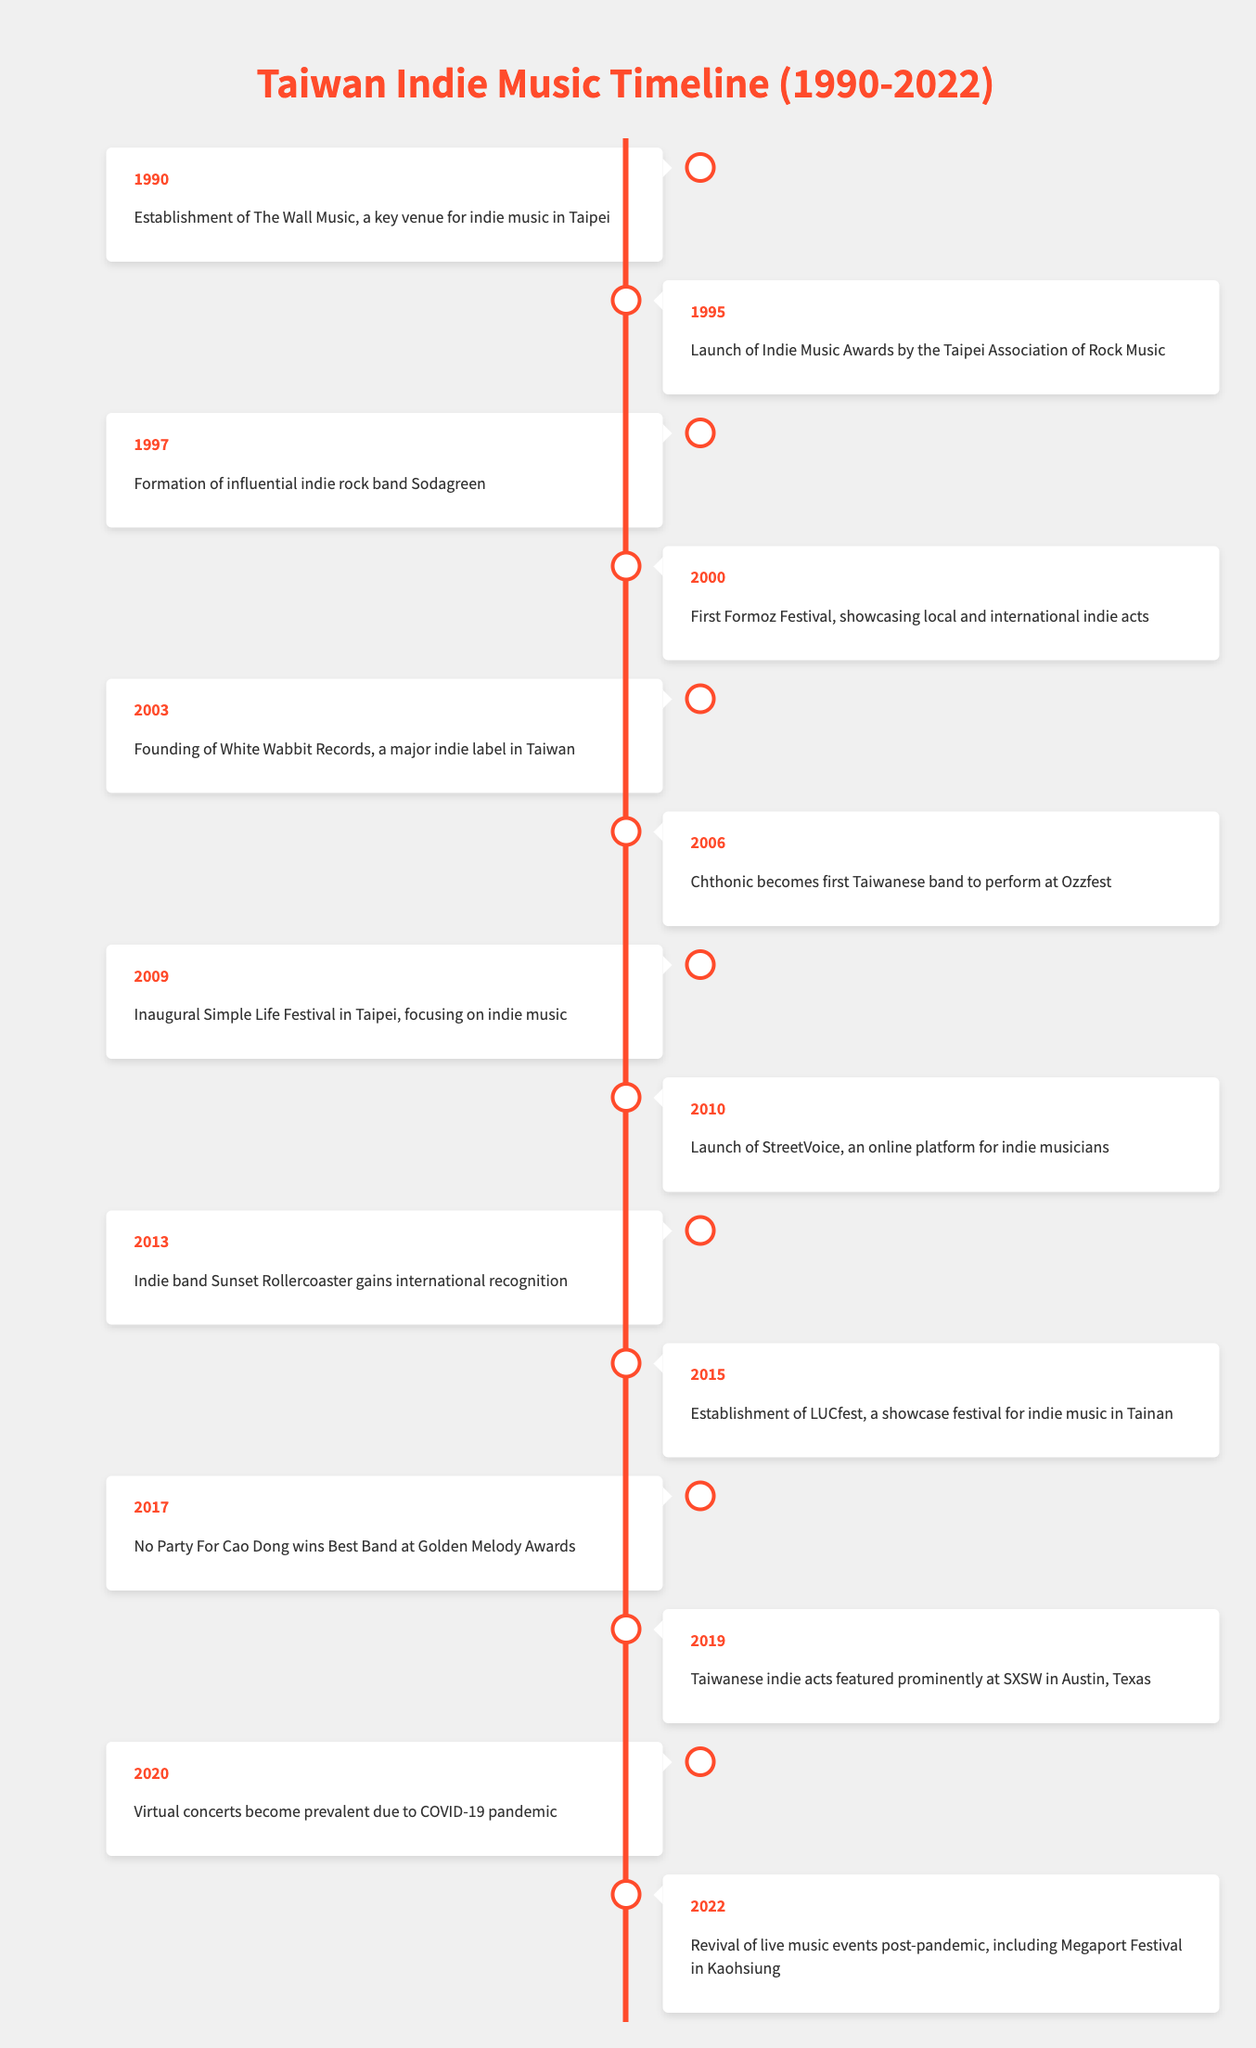What year was the first Formoz Festival held? According to the table, the first Formoz Festival took place in the year 2000.
Answer: 2000 Which indie band gained international recognition in 2013? The table indicates that the indie band Sunset Rollercoaster gained international recognition in the year 2013.
Answer: Sunset Rollercoaster How many key events occurred in the 1990s? By reviewing the table, there are 3 key events listed for the 1990s (in 1990, 1995, and 1997).
Answer: 3 Did any Taiwanese indie acts perform at SXSW in 2019? The data shows that Taiwanese indie acts were featured prominently at SXSW in 2019, confirming this fact as true.
Answer: Yes What event marked the establishment of a major indie label in Taiwan, and in what year did it happen? The founding of White Wabbit Records was the establishment of a major indie label in Taiwan, which occurred in 2003.
Answer: Founding of White Wabbit Records, 2003 Which year saw the revival of live music events post-pandemic? The table states that the revival of live music events post-pandemic occurred in 2022, including the Megaport Festival in Kaohsiung.
Answer: 2022 How many years apart were the establishment of The Wall Music and the launch of the Indie Music Awards? The Wall Music was established in 1990 and the Indie Music Awards were launched in 1995. The difference in years is 1995 - 1990 = 5 years.
Answer: 5 years Was Chthonic the first Taiwanese band to perform at Ozzfest? The table clearly states that in 2006, Chthonic became the first Taiwanese band to perform at Ozzfest, so this is true.
Answer: Yes How many events took place between 2010 and 2020? Referring to the table, the years 2010, 2013, 2015, 2017, 2019, and 2020 have events listed, which totals 6 events (10, 13, 15, 17, 19, and 20).
Answer: 6 